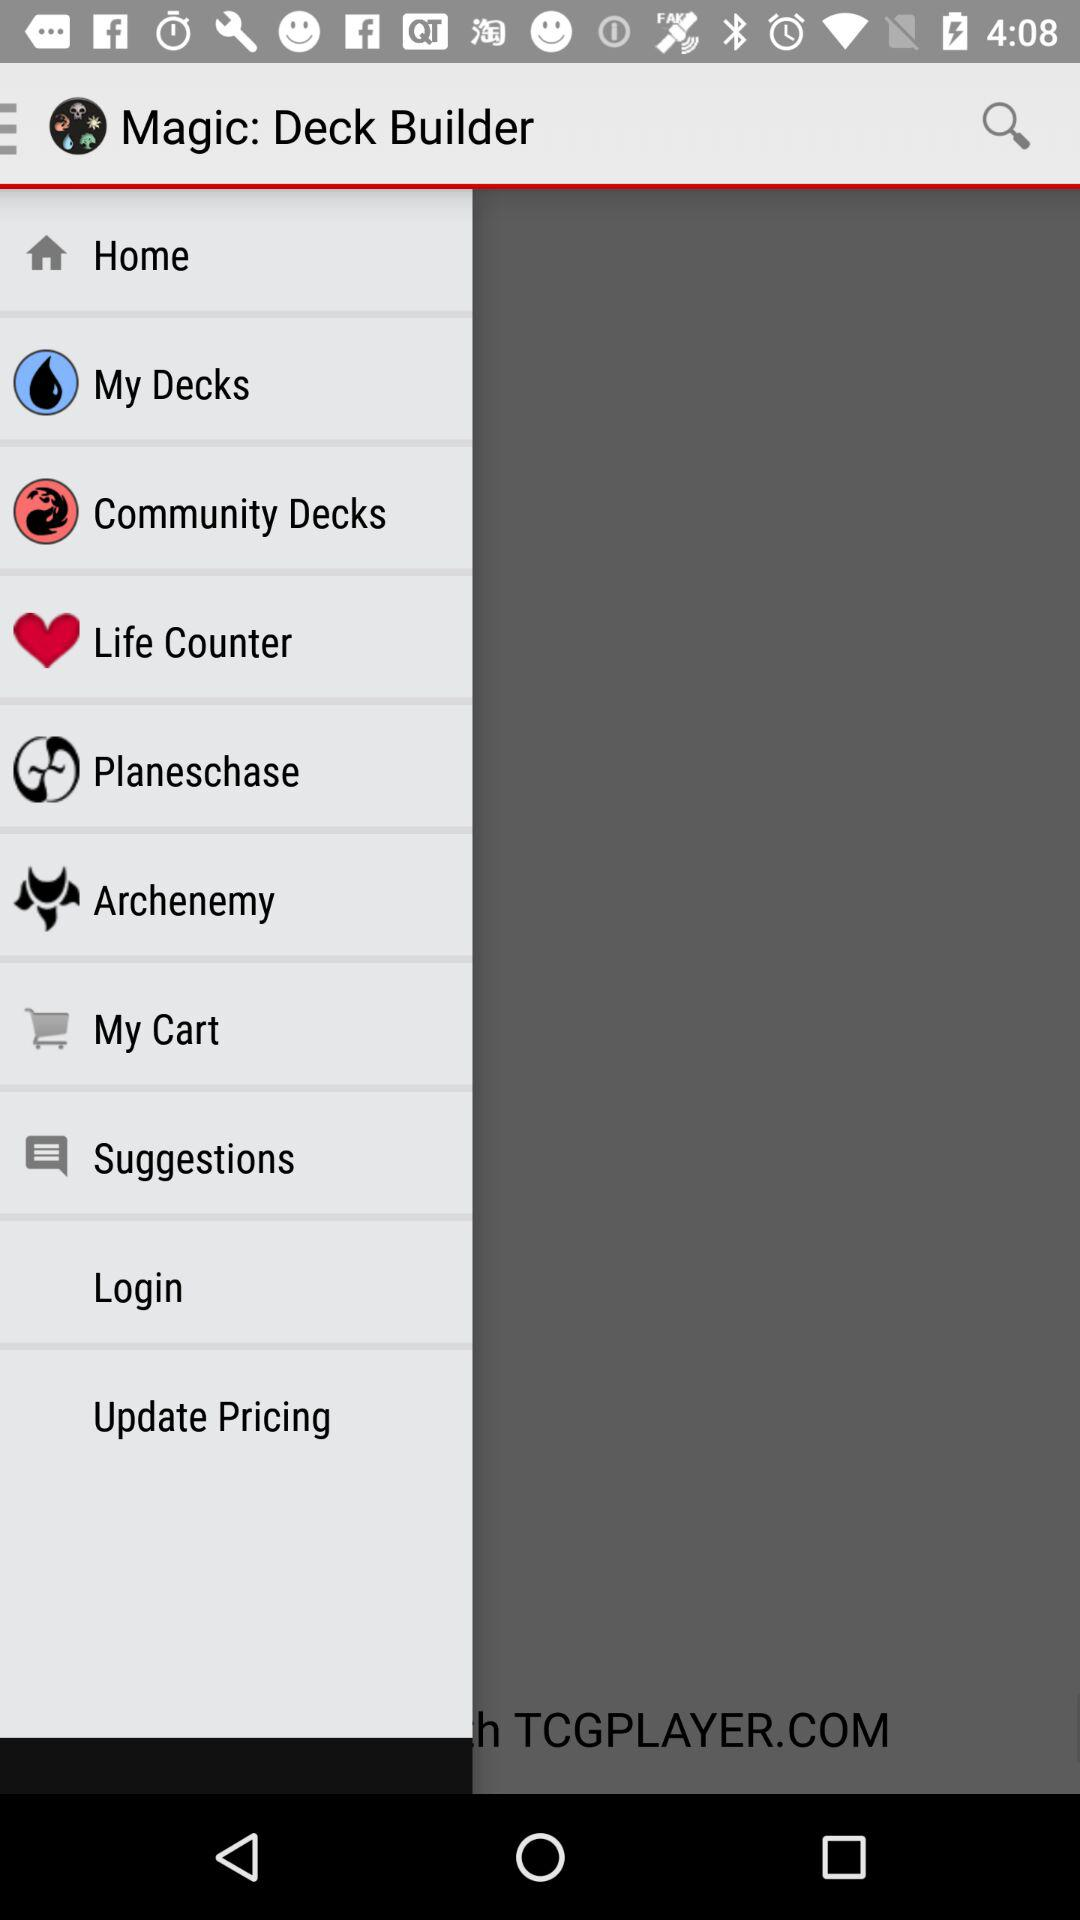What is the application name? The application name is "Magic: Deck B...". 